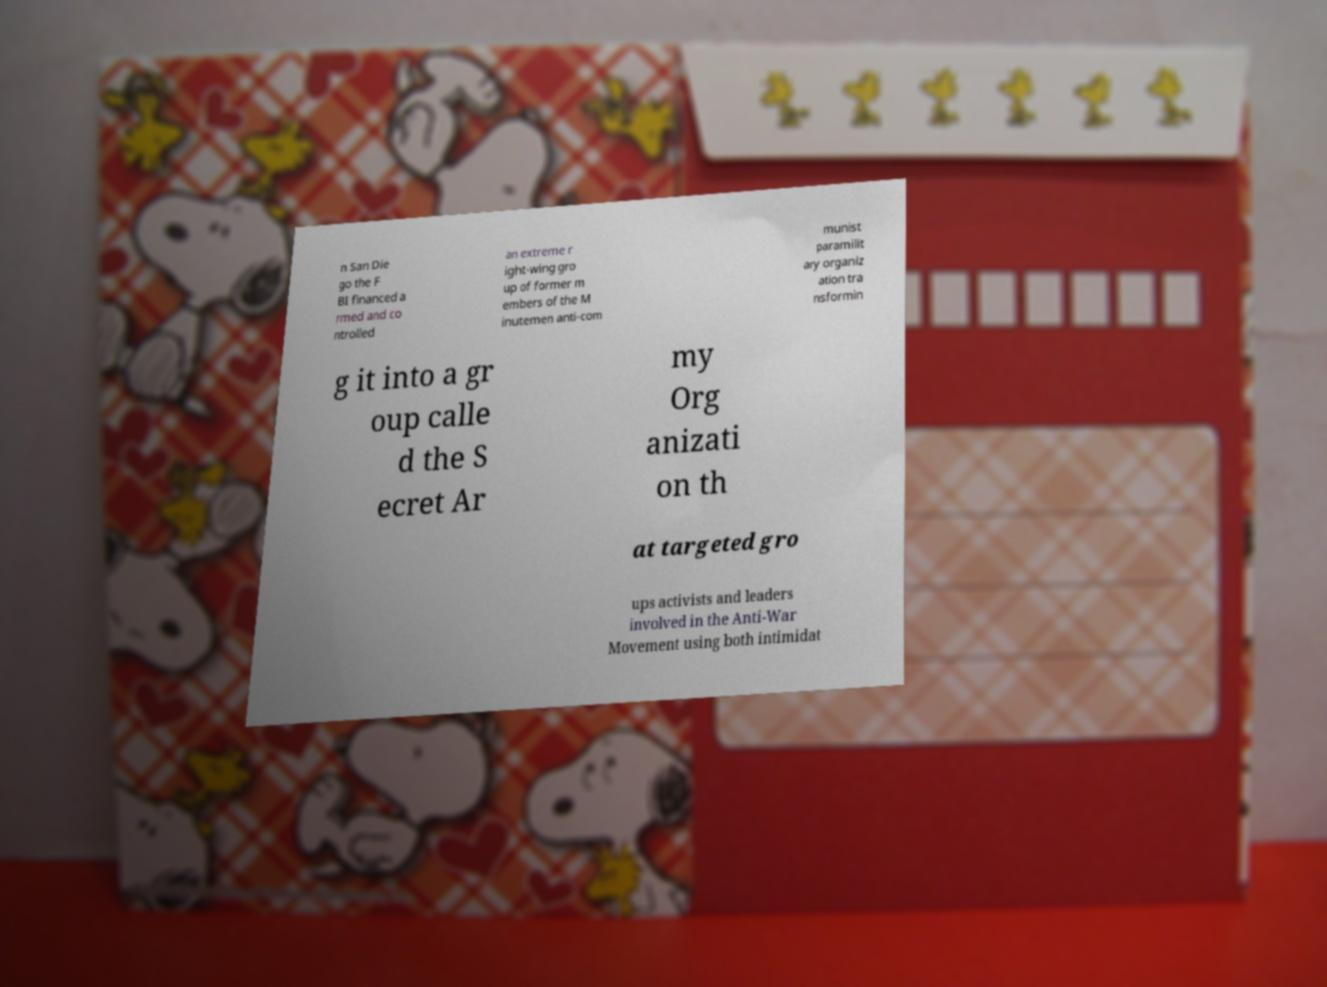What messages or text are displayed in this image? I need them in a readable, typed format. n San Die go the F BI financed a rmed and co ntrolled an extreme r ight-wing gro up of former m embers of the M inutemen anti-com munist paramilit ary organiz ation tra nsformin g it into a gr oup calle d the S ecret Ar my Org anizati on th at targeted gro ups activists and leaders involved in the Anti-War Movement using both intimidat 